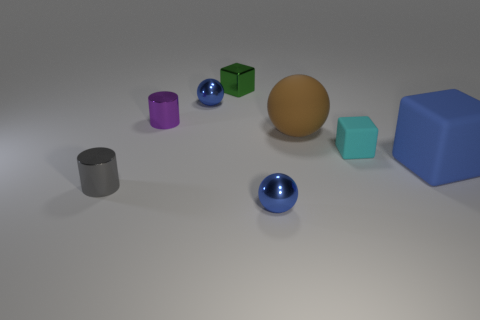The blue matte cube is what size?
Give a very brief answer. Large. There is a metal block; is its color the same as the metal sphere that is behind the large brown matte sphere?
Your answer should be very brief. No. How many other things are the same color as the metal cube?
Your response must be concise. 0. Is the size of the object that is on the left side of the purple cylinder the same as the metallic ball that is right of the small metallic cube?
Your answer should be compact. Yes. The metal cylinder in front of the small purple shiny cylinder is what color?
Make the answer very short. Gray. Are there fewer blue matte blocks that are in front of the big block than large brown balls?
Provide a succinct answer. Yes. Is the material of the small purple cylinder the same as the brown sphere?
Offer a terse response. No. What size is the other matte object that is the same shape as the large blue matte object?
Offer a very short reply. Small. How many objects are metal objects in front of the tiny gray cylinder or small metal balls in front of the tiny purple thing?
Provide a succinct answer. 1. Is the number of small metallic cylinders less than the number of green cylinders?
Offer a terse response. No. 